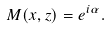<formula> <loc_0><loc_0><loc_500><loc_500>M ( x , z ) = e ^ { i \alpha } .</formula> 